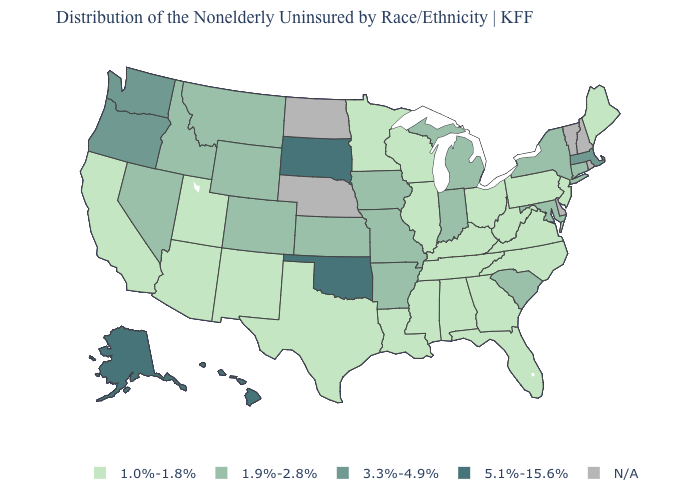Name the states that have a value in the range N/A?
Be succinct. Delaware, Nebraska, New Hampshire, North Dakota, Rhode Island, Vermont. What is the highest value in the USA?
Quick response, please. 5.1%-15.6%. What is the value of Utah?
Write a very short answer. 1.0%-1.8%. What is the value of Kansas?
Keep it brief. 1.9%-2.8%. What is the value of New Hampshire?
Answer briefly. N/A. What is the highest value in the USA?
Be succinct. 5.1%-15.6%. Name the states that have a value in the range 3.3%-4.9%?
Concise answer only. Massachusetts, Oregon, Washington. What is the value of Iowa?
Be succinct. 1.9%-2.8%. Name the states that have a value in the range 5.1%-15.6%?
Short answer required. Alaska, Hawaii, Oklahoma, South Dakota. Name the states that have a value in the range 3.3%-4.9%?
Write a very short answer. Massachusetts, Oregon, Washington. What is the value of Ohio?
Keep it brief. 1.0%-1.8%. What is the highest value in states that border Ohio?
Be succinct. 1.9%-2.8%. Does Oklahoma have the highest value in the South?
Quick response, please. Yes. What is the lowest value in states that border Pennsylvania?
Concise answer only. 1.0%-1.8%. Among the states that border Kansas , does Oklahoma have the lowest value?
Be succinct. No. 